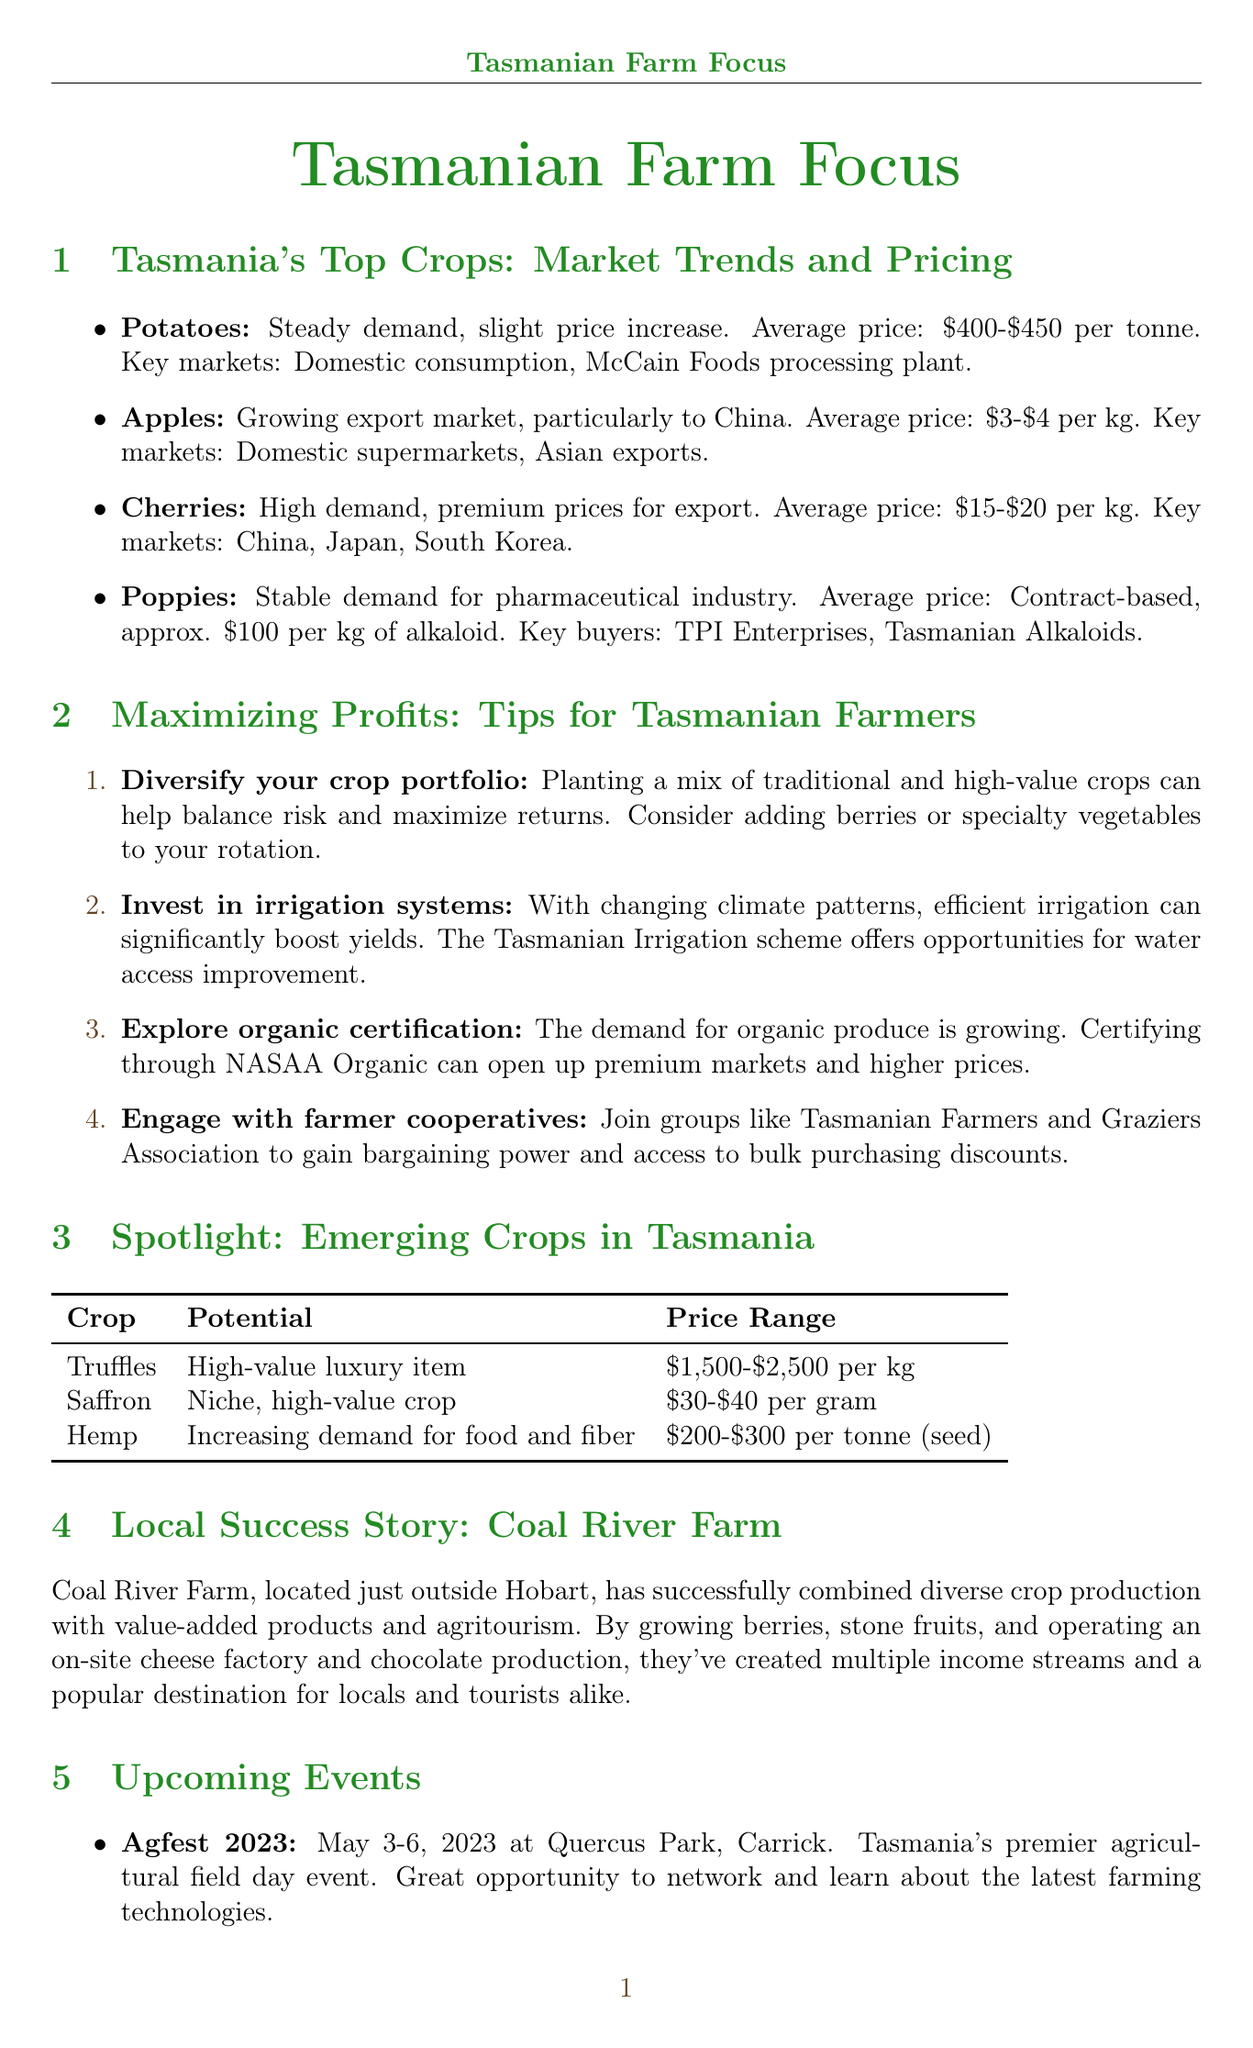What is the average price range for apples? The average price range for apples provided in the document is between $3 and $4 per kg.
Answer: $3-$4 per kg What climates are truffles grown in? The document states that truffles are produced in high-value luxury item settings, specifically noted regions are Deloraine and Launceston.
Answer: Deloraine, Launceston area What is a recommended tip for Tasmanian farmers regarding crops? The document highlights diversifying the crop portfolio as a strategy for maximizing profits.
Answer: Diversify your crop portfolio Which event focuses on orchard management? The Tasmanian Fruit Growers Conference focuses on orchard management, as mentioned in the events section.
Answer: Tasmanian Fruit Growers Conference What is the main market for Tasmanian cherries? The document notes that the primary markets for cherries include China, Japan, and South Korea.
Answer: China, Japan, South Korea What is the price range for saffron? The price range for saffron as indicated in the document is between $30 and $40 per gram.
Answer: $30-$40 per gram How does Coal River Farm generate income? Coal River Farm combines diverse crop production with value-added products and agritourism for generating income, as detailed in the success story.
Answer: Diverse crop production and agritourism What is a benefit of engaging with farmer cooperatives? Engaging with farmer cooperatives can lead to bargaining power and access to bulk purchasing discounts, as outlined in the tips for maximizing profits.
Answer: Bargaining power and bulk purchasing discounts 